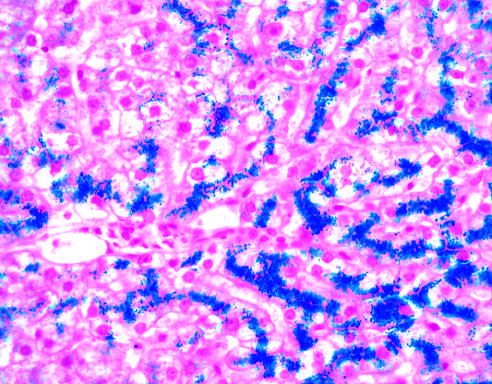s the parenchymal architecture normal at this stage of disease, even with such abundant iron?
Answer the question using a single word or phrase. Yes 